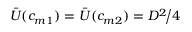<formula> <loc_0><loc_0><loc_500><loc_500>\bar { U } ( c _ { m 1 } ) = \bar { U } ( c _ { m 2 } ) = D ^ { 2 } \, \Big / 4</formula> 